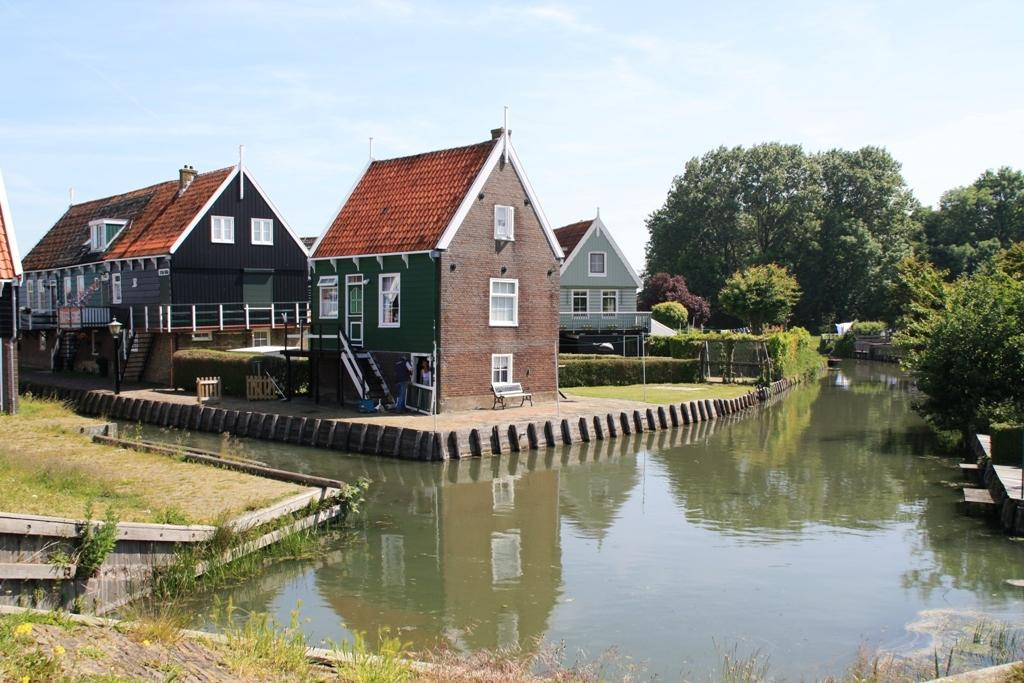What type of structures can be seen in the image? There are houses in the image. What type of seating is present in the image? There is a bench in the image. What type of barrier can be seen in the image? There is a fence in the image. What type of vertical structure can be seen in the image? There is a pole in the image. What type of terrain is present in the image? There is grassy land in the image. What type of natural feature can be seen in the image? There is a water body in the image. What type of vegetation can be seen in the image? There are trees in the image. What is visible at the top of the image? The sky is visible at the top of the image. What type of company is represented by the houses in the image? The houses in the image do not represent a company; they are residential structures. Can you see a kitty playing on the grassy land in the image? There is no kitty present in the image; only houses, a bench, a fence, a pole, a water body, trees, and the sky are visible. 